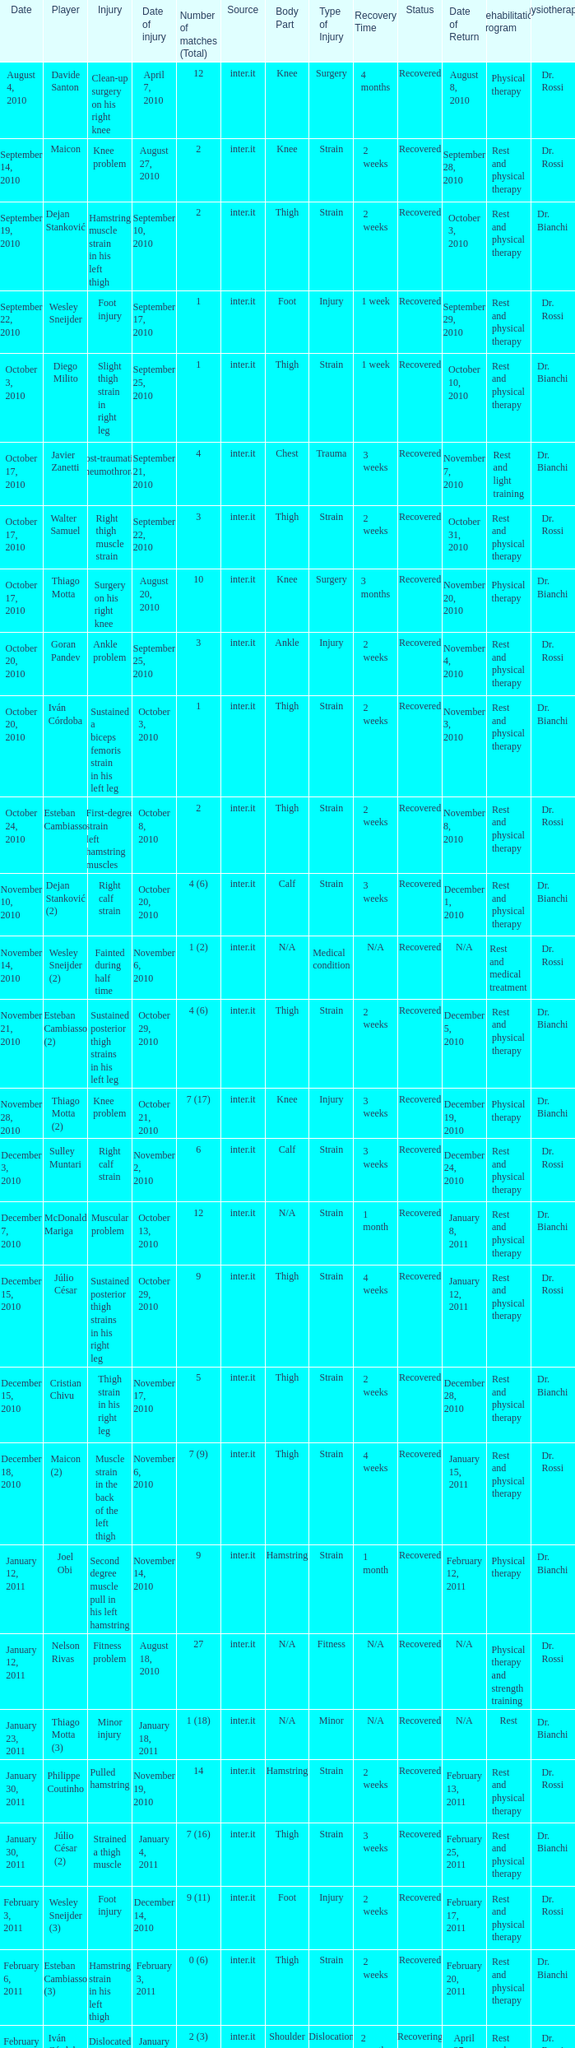How many times was the date october 3, 2010? 1.0. 